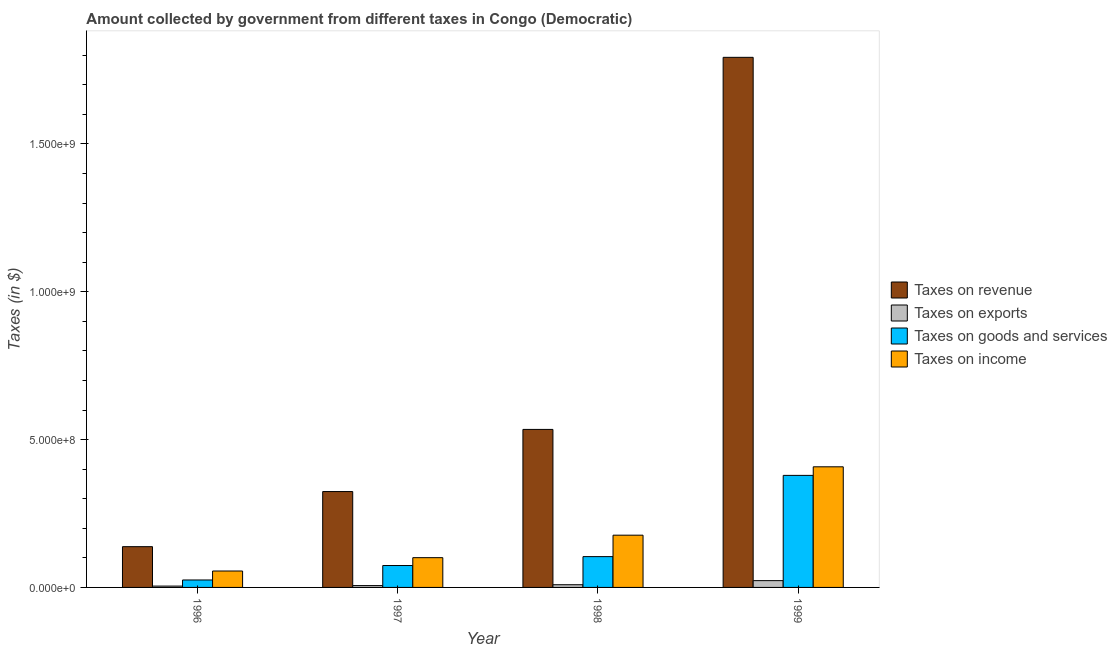Are the number of bars per tick equal to the number of legend labels?
Make the answer very short. Yes. Are the number of bars on each tick of the X-axis equal?
Keep it short and to the point. Yes. How many bars are there on the 1st tick from the left?
Provide a succinct answer. 4. How many bars are there on the 3rd tick from the right?
Your answer should be compact. 4. What is the label of the 3rd group of bars from the left?
Your answer should be compact. 1998. In how many cases, is the number of bars for a given year not equal to the number of legend labels?
Your answer should be compact. 0. What is the amount collected as tax on exports in 1996?
Provide a short and direct response. 4.53e+06. Across all years, what is the maximum amount collected as tax on exports?
Make the answer very short. 2.30e+07. Across all years, what is the minimum amount collected as tax on goods?
Give a very brief answer. 2.52e+07. In which year was the amount collected as tax on revenue maximum?
Ensure brevity in your answer.  1999. What is the total amount collected as tax on goods in the graph?
Provide a short and direct response. 5.82e+08. What is the difference between the amount collected as tax on income in 1998 and that in 1999?
Your answer should be very brief. -2.31e+08. What is the difference between the amount collected as tax on revenue in 1998 and the amount collected as tax on exports in 1996?
Give a very brief answer. 3.97e+08. What is the average amount collected as tax on revenue per year?
Ensure brevity in your answer.  6.97e+08. In the year 1998, what is the difference between the amount collected as tax on revenue and amount collected as tax on exports?
Ensure brevity in your answer.  0. In how many years, is the amount collected as tax on income greater than 700000000 $?
Make the answer very short. 0. What is the ratio of the amount collected as tax on goods in 1996 to that in 1999?
Ensure brevity in your answer.  0.07. Is the difference between the amount collected as tax on exports in 1996 and 1999 greater than the difference between the amount collected as tax on revenue in 1996 and 1999?
Ensure brevity in your answer.  No. What is the difference between the highest and the second highest amount collected as tax on exports?
Your answer should be compact. 1.39e+07. What is the difference between the highest and the lowest amount collected as tax on income?
Keep it short and to the point. 3.52e+08. In how many years, is the amount collected as tax on exports greater than the average amount collected as tax on exports taken over all years?
Offer a very short reply. 1. Is the sum of the amount collected as tax on goods in 1996 and 1998 greater than the maximum amount collected as tax on exports across all years?
Offer a very short reply. No. Is it the case that in every year, the sum of the amount collected as tax on goods and amount collected as tax on income is greater than the sum of amount collected as tax on revenue and amount collected as tax on exports?
Give a very brief answer. Yes. What does the 3rd bar from the left in 1999 represents?
Make the answer very short. Taxes on goods and services. What does the 4th bar from the right in 1996 represents?
Give a very brief answer. Taxes on revenue. How many bars are there?
Keep it short and to the point. 16. Are all the bars in the graph horizontal?
Provide a short and direct response. No. How many years are there in the graph?
Keep it short and to the point. 4. What is the difference between two consecutive major ticks on the Y-axis?
Make the answer very short. 5.00e+08. Does the graph contain grids?
Offer a terse response. No. How many legend labels are there?
Keep it short and to the point. 4. How are the legend labels stacked?
Your response must be concise. Vertical. What is the title of the graph?
Give a very brief answer. Amount collected by government from different taxes in Congo (Democratic). What is the label or title of the Y-axis?
Make the answer very short. Taxes (in $). What is the Taxes (in $) in Taxes on revenue in 1996?
Your response must be concise. 1.38e+08. What is the Taxes (in $) in Taxes on exports in 1996?
Your response must be concise. 4.53e+06. What is the Taxes (in $) in Taxes on goods and services in 1996?
Keep it short and to the point. 2.52e+07. What is the Taxes (in $) in Taxes on income in 1996?
Provide a short and direct response. 5.55e+07. What is the Taxes (in $) of Taxes on revenue in 1997?
Provide a succinct answer. 3.24e+08. What is the Taxes (in $) of Taxes on exports in 1997?
Keep it short and to the point. 6.24e+06. What is the Taxes (in $) in Taxes on goods and services in 1997?
Your answer should be compact. 7.41e+07. What is the Taxes (in $) of Taxes on income in 1997?
Make the answer very short. 1.01e+08. What is the Taxes (in $) of Taxes on revenue in 1998?
Ensure brevity in your answer.  5.34e+08. What is the Taxes (in $) of Taxes on exports in 1998?
Ensure brevity in your answer.  9.11e+06. What is the Taxes (in $) of Taxes on goods and services in 1998?
Your answer should be very brief. 1.04e+08. What is the Taxes (in $) in Taxes on income in 1998?
Your answer should be compact. 1.77e+08. What is the Taxes (in $) in Taxes on revenue in 1999?
Your response must be concise. 1.79e+09. What is the Taxes (in $) of Taxes on exports in 1999?
Your answer should be very brief. 2.30e+07. What is the Taxes (in $) of Taxes on goods and services in 1999?
Offer a terse response. 3.79e+08. What is the Taxes (in $) in Taxes on income in 1999?
Your answer should be compact. 4.08e+08. Across all years, what is the maximum Taxes (in $) in Taxes on revenue?
Provide a short and direct response. 1.79e+09. Across all years, what is the maximum Taxes (in $) in Taxes on exports?
Keep it short and to the point. 2.30e+07. Across all years, what is the maximum Taxes (in $) in Taxes on goods and services?
Ensure brevity in your answer.  3.79e+08. Across all years, what is the maximum Taxes (in $) in Taxes on income?
Offer a terse response. 4.08e+08. Across all years, what is the minimum Taxes (in $) of Taxes on revenue?
Make the answer very short. 1.38e+08. Across all years, what is the minimum Taxes (in $) of Taxes on exports?
Give a very brief answer. 4.53e+06. Across all years, what is the minimum Taxes (in $) in Taxes on goods and services?
Ensure brevity in your answer.  2.52e+07. Across all years, what is the minimum Taxes (in $) in Taxes on income?
Give a very brief answer. 5.55e+07. What is the total Taxes (in $) of Taxes on revenue in the graph?
Your response must be concise. 2.79e+09. What is the total Taxes (in $) in Taxes on exports in the graph?
Your answer should be very brief. 4.29e+07. What is the total Taxes (in $) in Taxes on goods and services in the graph?
Keep it short and to the point. 5.82e+08. What is the total Taxes (in $) of Taxes on income in the graph?
Provide a short and direct response. 7.41e+08. What is the difference between the Taxes (in $) of Taxes on revenue in 1996 and that in 1997?
Make the answer very short. -1.86e+08. What is the difference between the Taxes (in $) of Taxes on exports in 1996 and that in 1997?
Your response must be concise. -1.71e+06. What is the difference between the Taxes (in $) of Taxes on goods and services in 1996 and that in 1997?
Make the answer very short. -4.89e+07. What is the difference between the Taxes (in $) of Taxes on income in 1996 and that in 1997?
Provide a succinct answer. -4.52e+07. What is the difference between the Taxes (in $) in Taxes on revenue in 1996 and that in 1998?
Keep it short and to the point. -3.97e+08. What is the difference between the Taxes (in $) of Taxes on exports in 1996 and that in 1998?
Your answer should be very brief. -4.58e+06. What is the difference between the Taxes (in $) in Taxes on goods and services in 1996 and that in 1998?
Give a very brief answer. -7.90e+07. What is the difference between the Taxes (in $) in Taxes on income in 1996 and that in 1998?
Ensure brevity in your answer.  -1.21e+08. What is the difference between the Taxes (in $) in Taxes on revenue in 1996 and that in 1999?
Keep it short and to the point. -1.66e+09. What is the difference between the Taxes (in $) of Taxes on exports in 1996 and that in 1999?
Your response must be concise. -1.85e+07. What is the difference between the Taxes (in $) of Taxes on goods and services in 1996 and that in 1999?
Give a very brief answer. -3.54e+08. What is the difference between the Taxes (in $) in Taxes on income in 1996 and that in 1999?
Keep it short and to the point. -3.52e+08. What is the difference between the Taxes (in $) of Taxes on revenue in 1997 and that in 1998?
Offer a terse response. -2.10e+08. What is the difference between the Taxes (in $) in Taxes on exports in 1997 and that in 1998?
Offer a very short reply. -2.87e+06. What is the difference between the Taxes (in $) of Taxes on goods and services in 1997 and that in 1998?
Your response must be concise. -3.02e+07. What is the difference between the Taxes (in $) in Taxes on income in 1997 and that in 1998?
Provide a short and direct response. -7.60e+07. What is the difference between the Taxes (in $) of Taxes on revenue in 1997 and that in 1999?
Your answer should be very brief. -1.47e+09. What is the difference between the Taxes (in $) in Taxes on exports in 1997 and that in 1999?
Keep it short and to the point. -1.68e+07. What is the difference between the Taxes (in $) in Taxes on goods and services in 1997 and that in 1999?
Offer a terse response. -3.05e+08. What is the difference between the Taxes (in $) of Taxes on income in 1997 and that in 1999?
Your answer should be compact. -3.07e+08. What is the difference between the Taxes (in $) of Taxes on revenue in 1998 and that in 1999?
Your answer should be compact. -1.26e+09. What is the difference between the Taxes (in $) of Taxes on exports in 1998 and that in 1999?
Keep it short and to the point. -1.39e+07. What is the difference between the Taxes (in $) of Taxes on goods and services in 1998 and that in 1999?
Offer a terse response. -2.75e+08. What is the difference between the Taxes (in $) in Taxes on income in 1998 and that in 1999?
Your answer should be compact. -2.31e+08. What is the difference between the Taxes (in $) of Taxes on revenue in 1996 and the Taxes (in $) of Taxes on exports in 1997?
Your answer should be very brief. 1.32e+08. What is the difference between the Taxes (in $) of Taxes on revenue in 1996 and the Taxes (in $) of Taxes on goods and services in 1997?
Offer a terse response. 6.38e+07. What is the difference between the Taxes (in $) of Taxes on revenue in 1996 and the Taxes (in $) of Taxes on income in 1997?
Give a very brief answer. 3.72e+07. What is the difference between the Taxes (in $) in Taxes on exports in 1996 and the Taxes (in $) in Taxes on goods and services in 1997?
Your answer should be very brief. -6.95e+07. What is the difference between the Taxes (in $) in Taxes on exports in 1996 and the Taxes (in $) in Taxes on income in 1997?
Your answer should be very brief. -9.62e+07. What is the difference between the Taxes (in $) of Taxes on goods and services in 1996 and the Taxes (in $) of Taxes on income in 1997?
Your answer should be very brief. -7.55e+07. What is the difference between the Taxes (in $) of Taxes on revenue in 1996 and the Taxes (in $) of Taxes on exports in 1998?
Provide a succinct answer. 1.29e+08. What is the difference between the Taxes (in $) of Taxes on revenue in 1996 and the Taxes (in $) of Taxes on goods and services in 1998?
Offer a terse response. 3.36e+07. What is the difference between the Taxes (in $) in Taxes on revenue in 1996 and the Taxes (in $) in Taxes on income in 1998?
Provide a short and direct response. -3.88e+07. What is the difference between the Taxes (in $) in Taxes on exports in 1996 and the Taxes (in $) in Taxes on goods and services in 1998?
Provide a short and direct response. -9.97e+07. What is the difference between the Taxes (in $) of Taxes on exports in 1996 and the Taxes (in $) of Taxes on income in 1998?
Make the answer very short. -1.72e+08. What is the difference between the Taxes (in $) in Taxes on goods and services in 1996 and the Taxes (in $) in Taxes on income in 1998?
Provide a short and direct response. -1.52e+08. What is the difference between the Taxes (in $) of Taxes on revenue in 1996 and the Taxes (in $) of Taxes on exports in 1999?
Offer a very short reply. 1.15e+08. What is the difference between the Taxes (in $) in Taxes on revenue in 1996 and the Taxes (in $) in Taxes on goods and services in 1999?
Ensure brevity in your answer.  -2.41e+08. What is the difference between the Taxes (in $) in Taxes on revenue in 1996 and the Taxes (in $) in Taxes on income in 1999?
Make the answer very short. -2.70e+08. What is the difference between the Taxes (in $) of Taxes on exports in 1996 and the Taxes (in $) of Taxes on goods and services in 1999?
Make the answer very short. -3.74e+08. What is the difference between the Taxes (in $) in Taxes on exports in 1996 and the Taxes (in $) in Taxes on income in 1999?
Your response must be concise. -4.03e+08. What is the difference between the Taxes (in $) in Taxes on goods and services in 1996 and the Taxes (in $) in Taxes on income in 1999?
Your answer should be compact. -3.83e+08. What is the difference between the Taxes (in $) of Taxes on revenue in 1997 and the Taxes (in $) of Taxes on exports in 1998?
Provide a succinct answer. 3.15e+08. What is the difference between the Taxes (in $) of Taxes on revenue in 1997 and the Taxes (in $) of Taxes on goods and services in 1998?
Give a very brief answer. 2.20e+08. What is the difference between the Taxes (in $) of Taxes on revenue in 1997 and the Taxes (in $) of Taxes on income in 1998?
Provide a succinct answer. 1.48e+08. What is the difference between the Taxes (in $) of Taxes on exports in 1997 and the Taxes (in $) of Taxes on goods and services in 1998?
Your response must be concise. -9.80e+07. What is the difference between the Taxes (in $) of Taxes on exports in 1997 and the Taxes (in $) of Taxes on income in 1998?
Your answer should be compact. -1.70e+08. What is the difference between the Taxes (in $) of Taxes on goods and services in 1997 and the Taxes (in $) of Taxes on income in 1998?
Give a very brief answer. -1.03e+08. What is the difference between the Taxes (in $) of Taxes on revenue in 1997 and the Taxes (in $) of Taxes on exports in 1999?
Offer a very short reply. 3.01e+08. What is the difference between the Taxes (in $) of Taxes on revenue in 1997 and the Taxes (in $) of Taxes on goods and services in 1999?
Offer a very short reply. -5.47e+07. What is the difference between the Taxes (in $) in Taxes on revenue in 1997 and the Taxes (in $) in Taxes on income in 1999?
Ensure brevity in your answer.  -8.37e+07. What is the difference between the Taxes (in $) of Taxes on exports in 1997 and the Taxes (in $) of Taxes on goods and services in 1999?
Your response must be concise. -3.73e+08. What is the difference between the Taxes (in $) of Taxes on exports in 1997 and the Taxes (in $) of Taxes on income in 1999?
Keep it short and to the point. -4.02e+08. What is the difference between the Taxes (in $) in Taxes on goods and services in 1997 and the Taxes (in $) in Taxes on income in 1999?
Keep it short and to the point. -3.34e+08. What is the difference between the Taxes (in $) in Taxes on revenue in 1998 and the Taxes (in $) in Taxes on exports in 1999?
Provide a short and direct response. 5.11e+08. What is the difference between the Taxes (in $) of Taxes on revenue in 1998 and the Taxes (in $) of Taxes on goods and services in 1999?
Offer a very short reply. 1.55e+08. What is the difference between the Taxes (in $) of Taxes on revenue in 1998 and the Taxes (in $) of Taxes on income in 1999?
Your answer should be compact. 1.26e+08. What is the difference between the Taxes (in $) in Taxes on exports in 1998 and the Taxes (in $) in Taxes on goods and services in 1999?
Offer a very short reply. -3.70e+08. What is the difference between the Taxes (in $) in Taxes on exports in 1998 and the Taxes (in $) in Taxes on income in 1999?
Make the answer very short. -3.99e+08. What is the difference between the Taxes (in $) of Taxes on goods and services in 1998 and the Taxes (in $) of Taxes on income in 1999?
Offer a very short reply. -3.04e+08. What is the average Taxes (in $) in Taxes on revenue per year?
Offer a very short reply. 6.97e+08. What is the average Taxes (in $) of Taxes on exports per year?
Offer a very short reply. 1.07e+07. What is the average Taxes (in $) in Taxes on goods and services per year?
Offer a very short reply. 1.46e+08. What is the average Taxes (in $) of Taxes on income per year?
Your answer should be very brief. 1.85e+08. In the year 1996, what is the difference between the Taxes (in $) of Taxes on revenue and Taxes (in $) of Taxes on exports?
Make the answer very short. 1.33e+08. In the year 1996, what is the difference between the Taxes (in $) in Taxes on revenue and Taxes (in $) in Taxes on goods and services?
Make the answer very short. 1.13e+08. In the year 1996, what is the difference between the Taxes (in $) of Taxes on revenue and Taxes (in $) of Taxes on income?
Your answer should be very brief. 8.24e+07. In the year 1996, what is the difference between the Taxes (in $) of Taxes on exports and Taxes (in $) of Taxes on goods and services?
Provide a short and direct response. -2.07e+07. In the year 1996, what is the difference between the Taxes (in $) in Taxes on exports and Taxes (in $) in Taxes on income?
Offer a very short reply. -5.10e+07. In the year 1996, what is the difference between the Taxes (in $) of Taxes on goods and services and Taxes (in $) of Taxes on income?
Your answer should be very brief. -3.03e+07. In the year 1997, what is the difference between the Taxes (in $) of Taxes on revenue and Taxes (in $) of Taxes on exports?
Provide a succinct answer. 3.18e+08. In the year 1997, what is the difference between the Taxes (in $) of Taxes on revenue and Taxes (in $) of Taxes on goods and services?
Give a very brief answer. 2.50e+08. In the year 1997, what is the difference between the Taxes (in $) in Taxes on revenue and Taxes (in $) in Taxes on income?
Make the answer very short. 2.24e+08. In the year 1997, what is the difference between the Taxes (in $) in Taxes on exports and Taxes (in $) in Taxes on goods and services?
Offer a terse response. -6.78e+07. In the year 1997, what is the difference between the Taxes (in $) of Taxes on exports and Taxes (in $) of Taxes on income?
Offer a terse response. -9.44e+07. In the year 1997, what is the difference between the Taxes (in $) in Taxes on goods and services and Taxes (in $) in Taxes on income?
Give a very brief answer. -2.66e+07. In the year 1998, what is the difference between the Taxes (in $) in Taxes on revenue and Taxes (in $) in Taxes on exports?
Your response must be concise. 5.25e+08. In the year 1998, what is the difference between the Taxes (in $) of Taxes on revenue and Taxes (in $) of Taxes on goods and services?
Make the answer very short. 4.30e+08. In the year 1998, what is the difference between the Taxes (in $) in Taxes on revenue and Taxes (in $) in Taxes on income?
Keep it short and to the point. 3.58e+08. In the year 1998, what is the difference between the Taxes (in $) in Taxes on exports and Taxes (in $) in Taxes on goods and services?
Offer a terse response. -9.51e+07. In the year 1998, what is the difference between the Taxes (in $) in Taxes on exports and Taxes (in $) in Taxes on income?
Provide a short and direct response. -1.68e+08. In the year 1998, what is the difference between the Taxes (in $) in Taxes on goods and services and Taxes (in $) in Taxes on income?
Offer a terse response. -7.25e+07. In the year 1999, what is the difference between the Taxes (in $) in Taxes on revenue and Taxes (in $) in Taxes on exports?
Your answer should be very brief. 1.77e+09. In the year 1999, what is the difference between the Taxes (in $) in Taxes on revenue and Taxes (in $) in Taxes on goods and services?
Make the answer very short. 1.41e+09. In the year 1999, what is the difference between the Taxes (in $) of Taxes on revenue and Taxes (in $) of Taxes on income?
Offer a terse response. 1.38e+09. In the year 1999, what is the difference between the Taxes (in $) of Taxes on exports and Taxes (in $) of Taxes on goods and services?
Make the answer very short. -3.56e+08. In the year 1999, what is the difference between the Taxes (in $) of Taxes on exports and Taxes (in $) of Taxes on income?
Provide a succinct answer. -3.85e+08. In the year 1999, what is the difference between the Taxes (in $) of Taxes on goods and services and Taxes (in $) of Taxes on income?
Your answer should be compact. -2.90e+07. What is the ratio of the Taxes (in $) in Taxes on revenue in 1996 to that in 1997?
Your response must be concise. 0.43. What is the ratio of the Taxes (in $) in Taxes on exports in 1996 to that in 1997?
Give a very brief answer. 0.73. What is the ratio of the Taxes (in $) in Taxes on goods and services in 1996 to that in 1997?
Keep it short and to the point. 0.34. What is the ratio of the Taxes (in $) of Taxes on income in 1996 to that in 1997?
Your answer should be compact. 0.55. What is the ratio of the Taxes (in $) of Taxes on revenue in 1996 to that in 1998?
Give a very brief answer. 0.26. What is the ratio of the Taxes (in $) of Taxes on exports in 1996 to that in 1998?
Provide a succinct answer. 0.5. What is the ratio of the Taxes (in $) of Taxes on goods and services in 1996 to that in 1998?
Your answer should be very brief. 0.24. What is the ratio of the Taxes (in $) of Taxes on income in 1996 to that in 1998?
Keep it short and to the point. 0.31. What is the ratio of the Taxes (in $) of Taxes on revenue in 1996 to that in 1999?
Ensure brevity in your answer.  0.08. What is the ratio of the Taxes (in $) in Taxes on exports in 1996 to that in 1999?
Your response must be concise. 0.2. What is the ratio of the Taxes (in $) of Taxes on goods and services in 1996 to that in 1999?
Your response must be concise. 0.07. What is the ratio of the Taxes (in $) of Taxes on income in 1996 to that in 1999?
Offer a terse response. 0.14. What is the ratio of the Taxes (in $) in Taxes on revenue in 1997 to that in 1998?
Give a very brief answer. 0.61. What is the ratio of the Taxes (in $) of Taxes on exports in 1997 to that in 1998?
Give a very brief answer. 0.68. What is the ratio of the Taxes (in $) in Taxes on goods and services in 1997 to that in 1998?
Give a very brief answer. 0.71. What is the ratio of the Taxes (in $) of Taxes on income in 1997 to that in 1998?
Your answer should be very brief. 0.57. What is the ratio of the Taxes (in $) in Taxes on revenue in 1997 to that in 1999?
Ensure brevity in your answer.  0.18. What is the ratio of the Taxes (in $) in Taxes on exports in 1997 to that in 1999?
Offer a terse response. 0.27. What is the ratio of the Taxes (in $) in Taxes on goods and services in 1997 to that in 1999?
Offer a very short reply. 0.2. What is the ratio of the Taxes (in $) in Taxes on income in 1997 to that in 1999?
Keep it short and to the point. 0.25. What is the ratio of the Taxes (in $) in Taxes on revenue in 1998 to that in 1999?
Give a very brief answer. 0.3. What is the ratio of the Taxes (in $) of Taxes on exports in 1998 to that in 1999?
Make the answer very short. 0.4. What is the ratio of the Taxes (in $) of Taxes on goods and services in 1998 to that in 1999?
Your answer should be compact. 0.28. What is the ratio of the Taxes (in $) of Taxes on income in 1998 to that in 1999?
Make the answer very short. 0.43. What is the difference between the highest and the second highest Taxes (in $) in Taxes on revenue?
Ensure brevity in your answer.  1.26e+09. What is the difference between the highest and the second highest Taxes (in $) of Taxes on exports?
Make the answer very short. 1.39e+07. What is the difference between the highest and the second highest Taxes (in $) in Taxes on goods and services?
Make the answer very short. 2.75e+08. What is the difference between the highest and the second highest Taxes (in $) in Taxes on income?
Your response must be concise. 2.31e+08. What is the difference between the highest and the lowest Taxes (in $) of Taxes on revenue?
Your answer should be very brief. 1.66e+09. What is the difference between the highest and the lowest Taxes (in $) in Taxes on exports?
Make the answer very short. 1.85e+07. What is the difference between the highest and the lowest Taxes (in $) of Taxes on goods and services?
Your response must be concise. 3.54e+08. What is the difference between the highest and the lowest Taxes (in $) of Taxes on income?
Offer a terse response. 3.52e+08. 